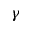<formula> <loc_0><loc_0><loc_500><loc_500>\gamma</formula> 